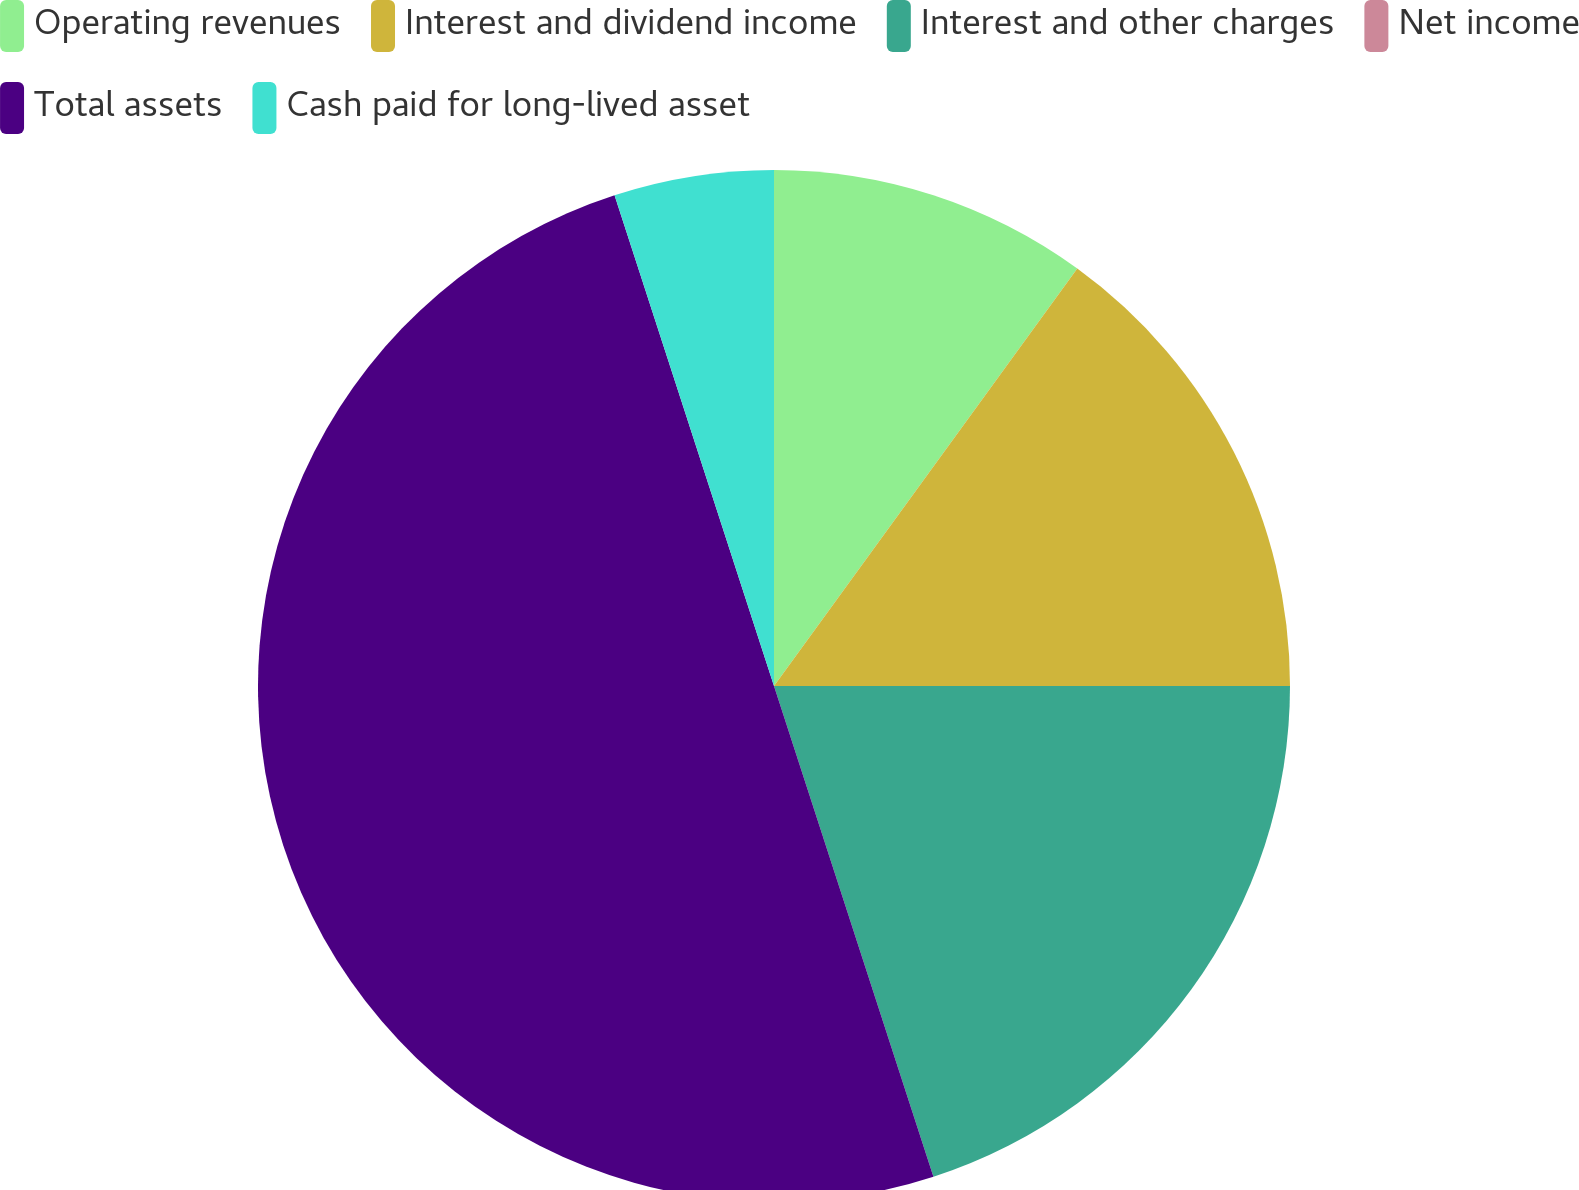<chart> <loc_0><loc_0><loc_500><loc_500><pie_chart><fcel>Operating revenues<fcel>Interest and dividend income<fcel>Interest and other charges<fcel>Net income<fcel>Total assets<fcel>Cash paid for long-lived asset<nl><fcel>10.0%<fcel>15.0%<fcel>20.0%<fcel>0.0%<fcel>50.0%<fcel>5.0%<nl></chart> 